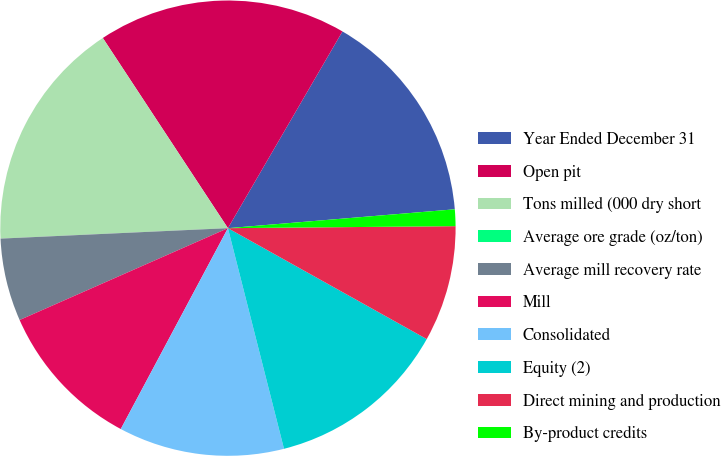Convert chart. <chart><loc_0><loc_0><loc_500><loc_500><pie_chart><fcel>Year Ended December 31<fcel>Open pit<fcel>Tons milled (000 dry short<fcel>Average ore grade (oz/ton)<fcel>Average mill recovery rate<fcel>Mill<fcel>Consolidated<fcel>Equity (2)<fcel>Direct mining and production<fcel>By-product credits<nl><fcel>15.29%<fcel>17.65%<fcel>16.47%<fcel>0.0%<fcel>5.88%<fcel>10.59%<fcel>11.76%<fcel>12.94%<fcel>8.24%<fcel>1.18%<nl></chart> 